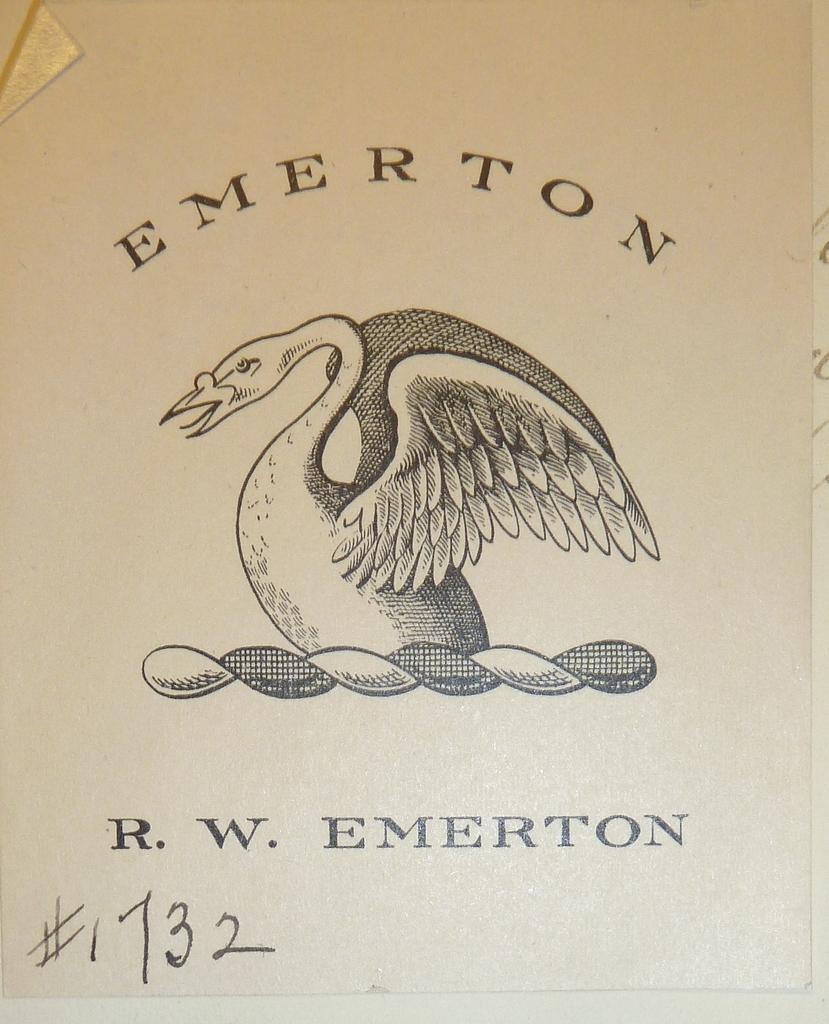Please provide a concise description of this image. In the image we can see this is a paper and there is a printed text and a bird on it. 